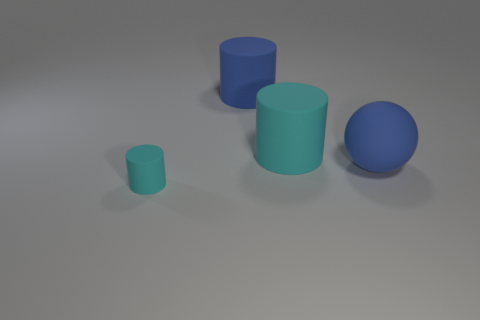What size is the blue matte thing that is the same shape as the tiny cyan rubber thing?
Your response must be concise. Large. There is a big blue thing left of the big matte ball; what shape is it?
Offer a very short reply. Cylinder. What is the color of the cylinder that is in front of the cyan matte cylinder on the right side of the tiny cylinder?
Your response must be concise. Cyan. There is a small rubber object that is the same shape as the large cyan rubber thing; what color is it?
Provide a succinct answer. Cyan. What number of big things are the same color as the small object?
Ensure brevity in your answer.  1. Do the sphere and the rubber cylinder behind the large cyan rubber object have the same color?
Ensure brevity in your answer.  Yes. What is the shape of the object that is both on the right side of the tiny cyan cylinder and in front of the large cyan object?
Keep it short and to the point. Sphere. Are there more cyan matte cylinders in front of the blue sphere than cylinders left of the small cyan cylinder?
Offer a terse response. Yes. What number of cylinders have the same material as the tiny object?
Ensure brevity in your answer.  2. There is a cyan matte thing on the right side of the tiny matte object; is it the same shape as the large blue thing that is to the right of the blue rubber cylinder?
Offer a terse response. No. 